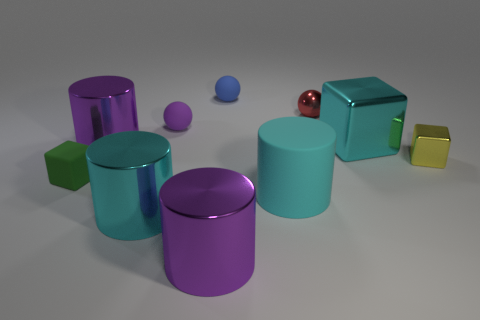Subtract 1 cylinders. How many cylinders are left? 3 Subtract all yellow cylinders. Subtract all yellow cubes. How many cylinders are left? 4 Subtract all cylinders. How many objects are left? 6 Subtract 1 cyan cubes. How many objects are left? 9 Subtract all tiny red shiny spheres. Subtract all tiny matte cubes. How many objects are left? 8 Add 6 matte cubes. How many matte cubes are left? 7 Add 7 small rubber blocks. How many small rubber blocks exist? 8 